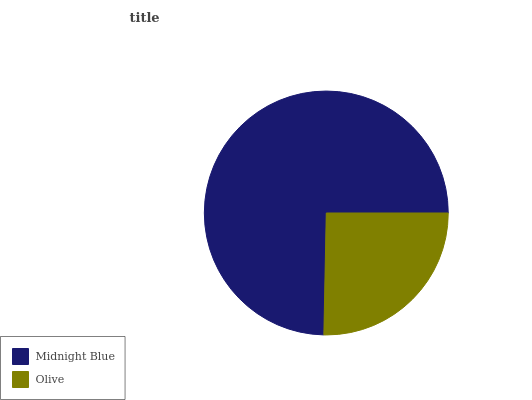Is Olive the minimum?
Answer yes or no. Yes. Is Midnight Blue the maximum?
Answer yes or no. Yes. Is Olive the maximum?
Answer yes or no. No. Is Midnight Blue greater than Olive?
Answer yes or no. Yes. Is Olive less than Midnight Blue?
Answer yes or no. Yes. Is Olive greater than Midnight Blue?
Answer yes or no. No. Is Midnight Blue less than Olive?
Answer yes or no. No. Is Midnight Blue the high median?
Answer yes or no. Yes. Is Olive the low median?
Answer yes or no. Yes. Is Olive the high median?
Answer yes or no. No. Is Midnight Blue the low median?
Answer yes or no. No. 